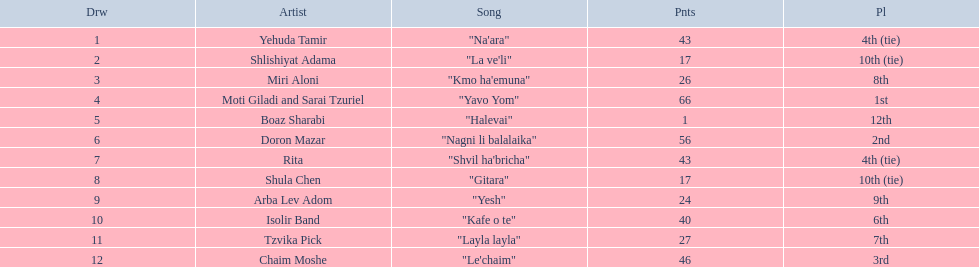Help me parse the entirety of this table. {'header': ['Drw', 'Artist', 'Song', 'Pnts', 'Pl'], 'rows': [['1', 'Yehuda Tamir', '"Na\'ara"', '43', '4th (tie)'], ['2', 'Shlishiyat Adama', '"La ve\'li"', '17', '10th (tie)'], ['3', 'Miri Aloni', '"Kmo ha\'emuna"', '26', '8th'], ['4', 'Moti Giladi and Sarai Tzuriel', '"Yavo Yom"', '66', '1st'], ['5', 'Boaz Sharabi', '"Halevai"', '1', '12th'], ['6', 'Doron Mazar', '"Nagni li balalaika"', '56', '2nd'], ['7', 'Rita', '"Shvil ha\'bricha"', '43', '4th (tie)'], ['8', 'Shula Chen', '"Gitara"', '17', '10th (tie)'], ['9', 'Arba Lev Adom', '"Yesh"', '24', '9th'], ['10', 'Isolir Band', '"Kafe o te"', '40', '6th'], ['11', 'Tzvika Pick', '"Layla layla"', '27', '7th'], ['12', 'Chaim Moshe', '"Le\'chaim"', '46', '3rd']]} Doron mazar, which artist(s) had the most points? Moti Giladi and Sarai Tzuriel. 